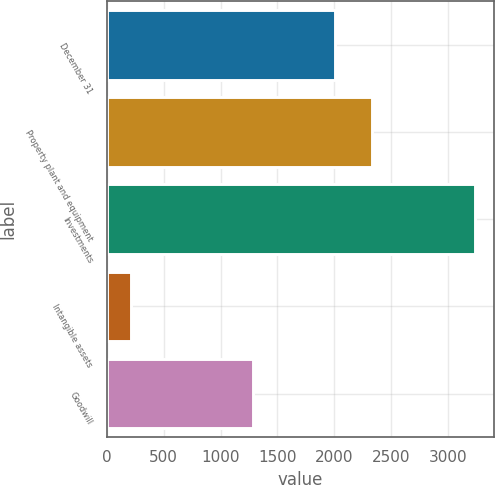Convert chart to OTSL. <chart><loc_0><loc_0><loc_500><loc_500><bar_chart><fcel>December 31<fcel>Property plant and equipment<fcel>Investments<fcel>Intangible assets<fcel>Goodwill<nl><fcel>2004<fcel>2332<fcel>3241<fcel>212<fcel>1283<nl></chart> 